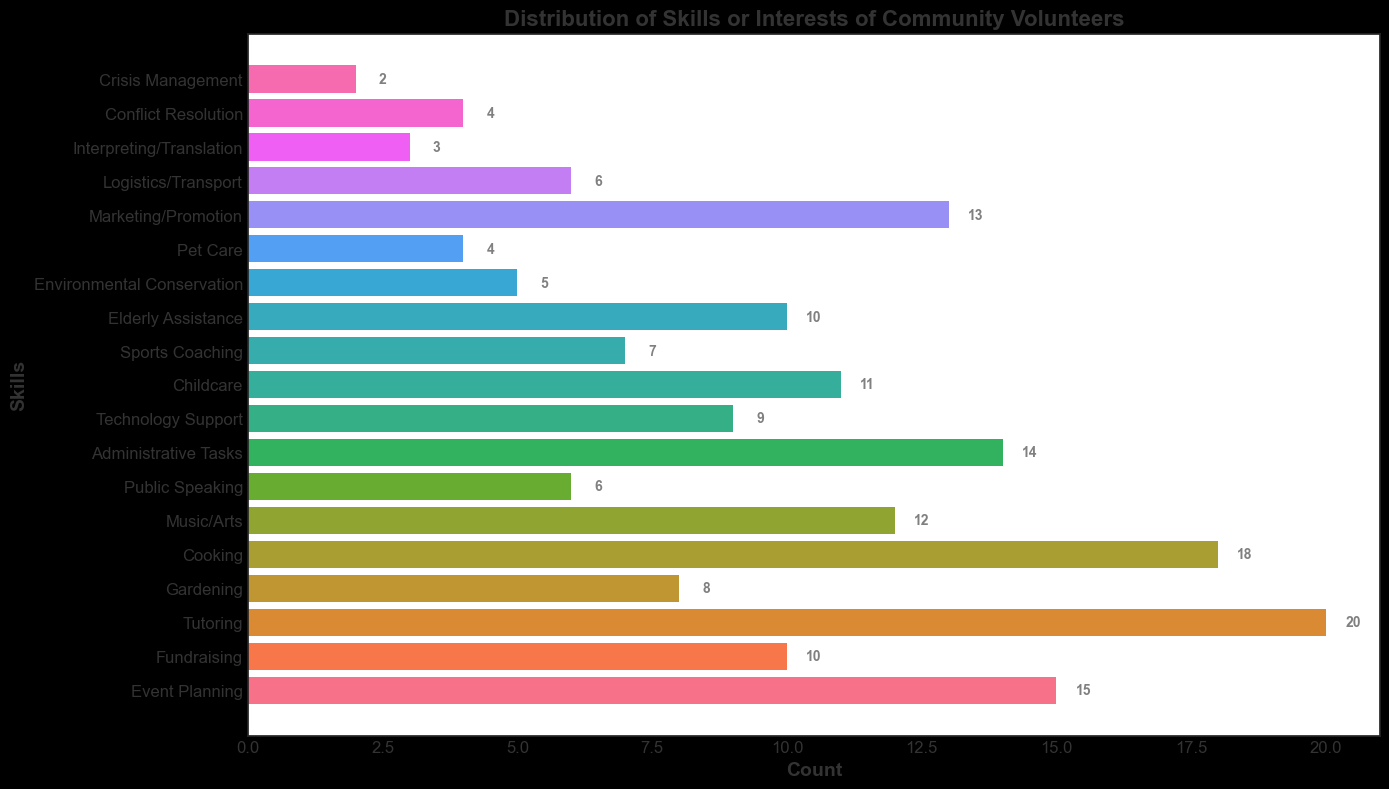What's the most common skill or interest among community volunteers? The tallest bar corresponds to "Tutoring," indicating it has the highest count among the listed skills or interests.
Answer: Tutoring How many more volunteers are interested in Cooking compared to Gardening? The bar representing Cooking has a height of 18, while the bar for Gardening has a height of 8. Subtract the count for Gardening from Cooking (18 - 8).
Answer: 10 Which skill has the fewest volunteers? The shortest bar corresponds to "Crisis Management," indicating it has the lowest count.
Answer: Crisis Management What are the total number of volunteers in the community center based on the given skills or interests? Sum all the counts from the bars: 15 + 10 + 20 + 8 + 18 + 12 + 6 + 14 + 9 + 11 + 7 + 10 + 5 + 4 + 13 + 6 + 3 + 4 + 2.
Answer: 177 Which is more popular: Administrative Tasks or Marketing/Promotion? Compare the heights of the bars representing Administrative Tasks (14) and Marketing/Promotion (13).
Answer: Administrative Tasks Are there more volunteers for Technology Support or Childcare? By how many? Technology Support has a count of 9, and Childcare has a count of 11. Subtract the count for Technology Support from Childcare (11 - 9).
Answer: Childcare by 2 What’s the combined count of volunteers in Pet Care and Environmental Conservation? Add the counts of Pet Care (4) and Environmental Conservation (5).
Answer: 9 Which two skills have the same number of volunteers? Compare the heights of the bars. Public Speaking and Logistics/Transport both have a count of 6.
Answer: Public Speaking and Logistics/Transport How does the number of volunteers for Elderly Assistance compare to Fundraising? The bar for Elderly Assistance has a count of 10, which is the same as the count for Fundraising.
Answer: Equal What’s the average number of volunteers per skill or interest? Divide the total number of volunteers (177) by the number of skills or interests (19).
Answer: 9.32 